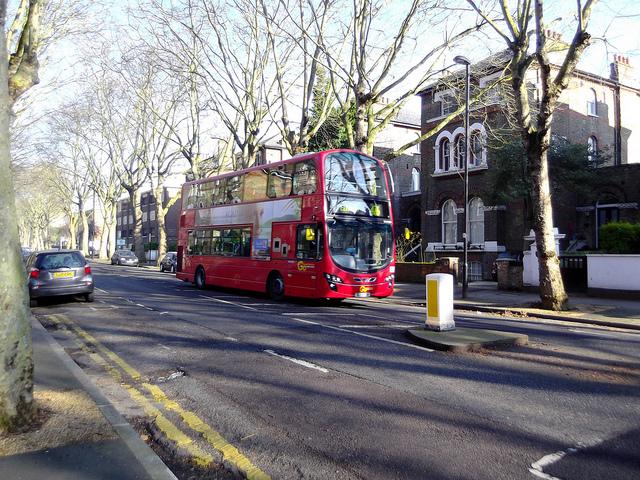Is the bus stopped?
Short answer required. No. Is this a two way street?
Quick response, please. Yes. In what city is this photo taken?
Quick response, please. London. What side of the road do the cars drive on?
Short answer required. Left. Does the street need to be fixed?
Keep it brief. Yes. What kind of traffic marker is standing in the middle of the road?
Quick response, please. Barrier. What is parked beside the curb?
Quick response, please. Car. 